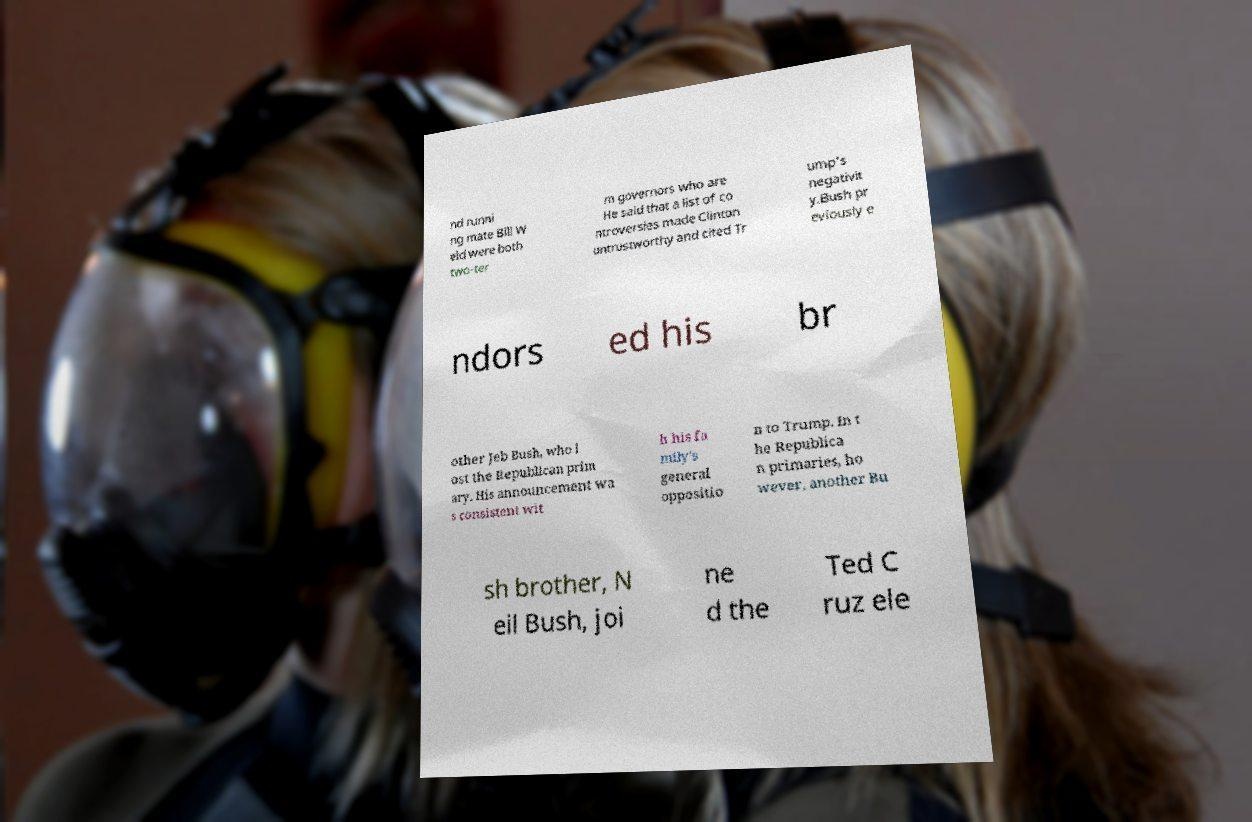Can you read and provide the text displayed in the image?This photo seems to have some interesting text. Can you extract and type it out for me? nd runni ng mate Bill W eld were both two-ter m governors who are He said that a list of co ntroversies made Clinton untrustworthy and cited Tr ump's negativit y.Bush pr eviously e ndors ed his br other Jeb Bush, who l ost the Republican prim ary. His announcement wa s consistent wit h his fa mily's general oppositio n to Trump. In t he Republica n primaries, ho wever, another Bu sh brother, N eil Bush, joi ne d the Ted C ruz ele 